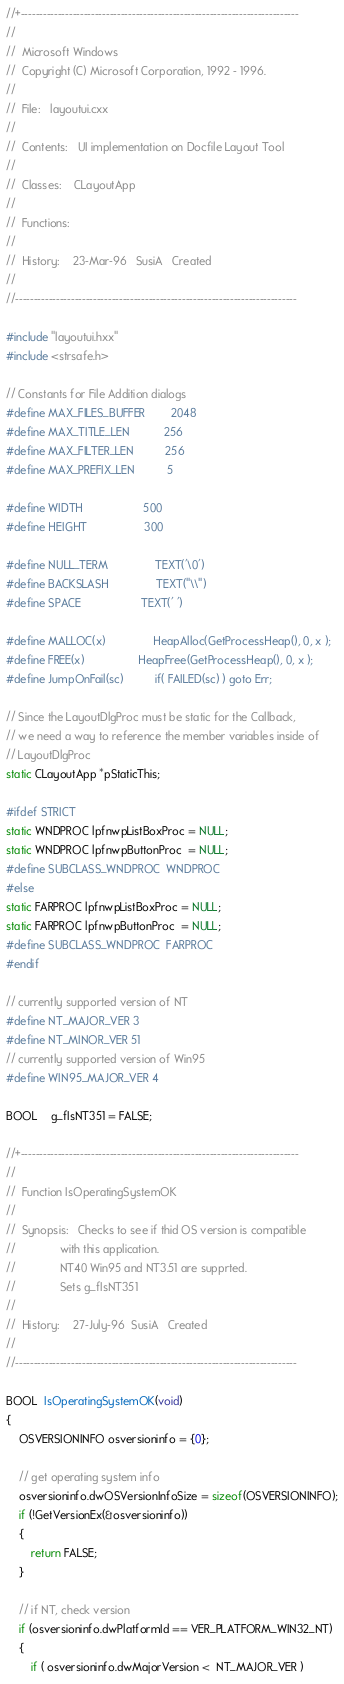Convert code to text. <code><loc_0><loc_0><loc_500><loc_500><_C++_>//+---------------------------------------------------------------------------
//
//  Microsoft Windows
//  Copyright (C) Microsoft Corporation, 1992 - 1996.
//
//  File:	layoutui.cxx
//
//  Contents:	UI implementation on Docfile Layout Tool
//
//  Classes:    CLayoutApp	
//
//  Functions:	
//
//  History:	23-Mar-96	SusiA	Created
//
//----------------------------------------------------------------------------

#include "layoutui.hxx"
#include <strsafe.h>

// Constants for File Addition dialogs
#define MAX_FILES_BUFFER        2048
#define MAX_TITLE_LEN           256
#define MAX_FILTER_LEN          256
#define MAX_PREFIX_LEN          5

#define WIDTH                   500
#define HEIGHT                  300

#define NULL_TERM               TEXT('\0')
#define BACKSLASH               TEXT("\\")
#define SPACE                   TEXT(' ')

#define MALLOC(x)               HeapAlloc(GetProcessHeap(), 0, x );
#define FREE(x)                 HeapFree(GetProcessHeap(), 0, x );
#define JumpOnFail(sc)          if( FAILED(sc) ) goto Err;

// Since the LayoutDlgProc must be static for the Callback,
// we need a way to reference the member variables inside of
// LayoutDlgProc
static CLayoutApp *pStaticThis;

#ifdef STRICT
static WNDPROC lpfnwpListBoxProc = NULL;
static WNDPROC lpfnwpButtonProc  = NULL;
#define SUBCLASS_WNDPROC  WNDPROC
#else
static FARPROC lpfnwpListBoxProc = NULL;
static FARPROC lpfnwpButtonProc  = NULL;
#define SUBCLASS_WNDPROC  FARPROC
#endif

// currently supported version of NT
#define NT_MAJOR_VER 3
#define NT_MINOR_VER 51
// currently supported version of Win95
#define WIN95_MAJOR_VER 4

BOOL 	g_fIsNT351 = FALSE;

//+---------------------------------------------------------------------------
//  
//  Function IsOperatingSystemOK
//  
//  Synopsis:	Checks to see if thid OS version is compatible
//              with this application. 
//              NT40 Win95 and NT3.51 are supprted.
//              Sets g_fIsNT351
//              
//  History:	27-July-96	SusiA	Created
//
//----------------------------------------------------------------------------

BOOL  IsOperatingSystemOK(void)
{
    OSVERSIONINFO osversioninfo = {0};

    // get operating system info
    osversioninfo.dwOSVersionInfoSize = sizeof(OSVERSIONINFO);
    if (!GetVersionEx(&osversioninfo))
    {
        return FALSE;
    }

    // if NT, check version
    if (osversioninfo.dwPlatformId == VER_PLATFORM_WIN32_NT)
    {
        if ( osversioninfo.dwMajorVersion <  NT_MAJOR_VER )</code> 